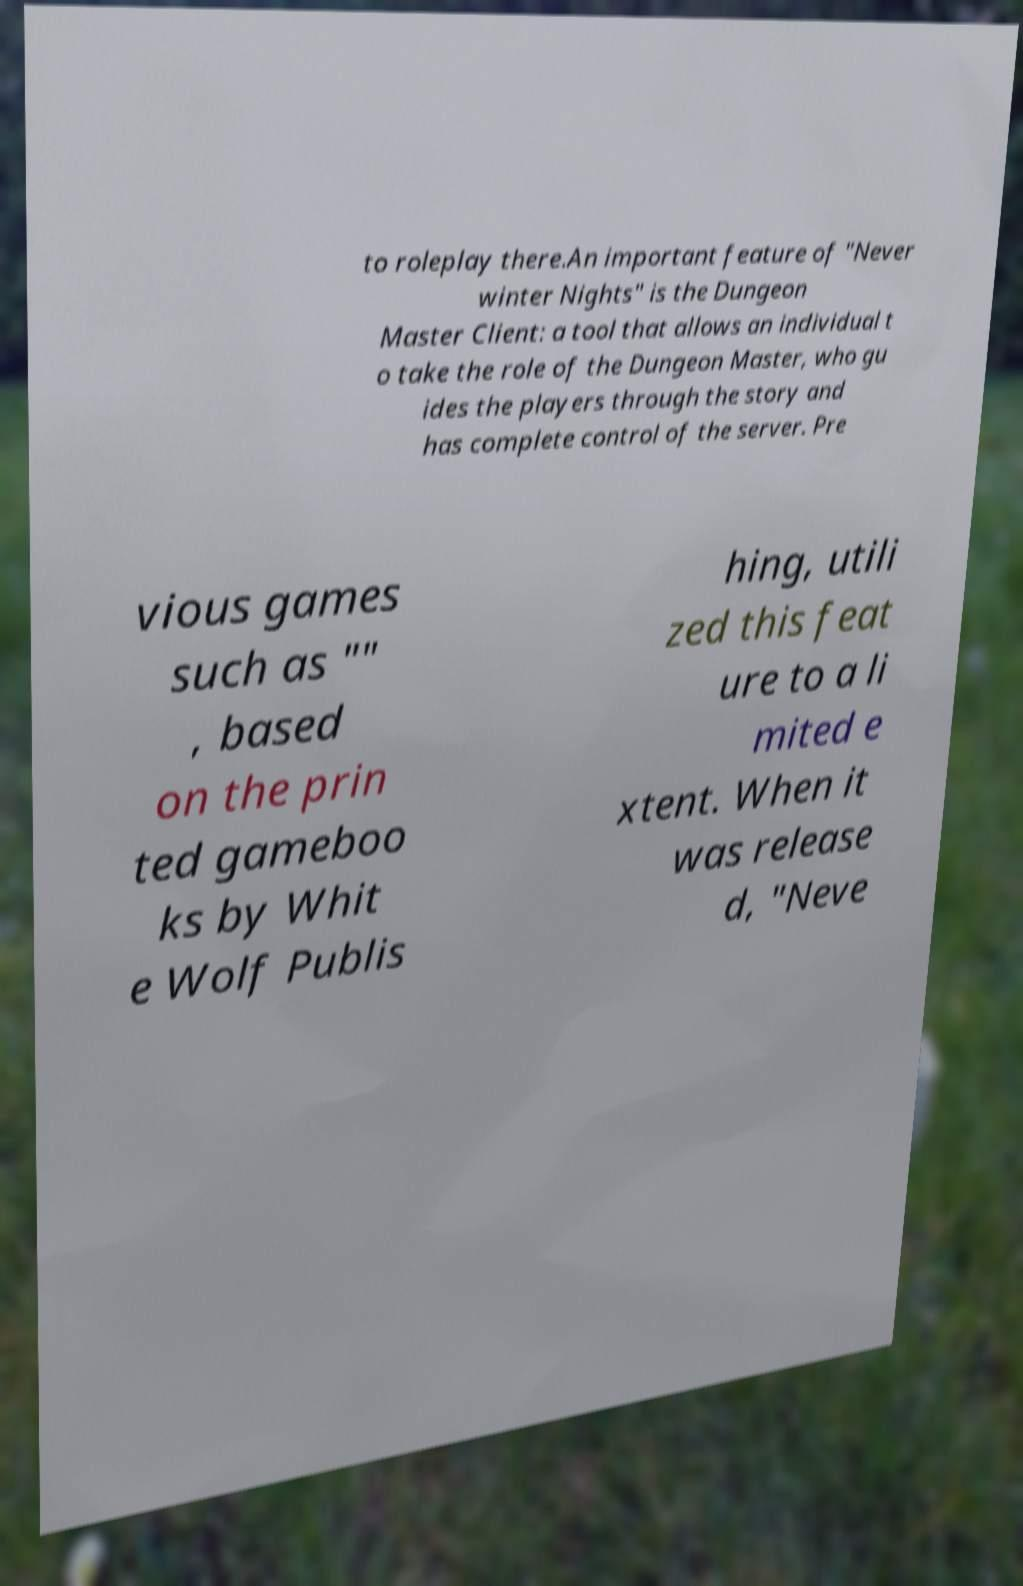Please read and relay the text visible in this image. What does it say? to roleplay there.An important feature of "Never winter Nights" is the Dungeon Master Client: a tool that allows an individual t o take the role of the Dungeon Master, who gu ides the players through the story and has complete control of the server. Pre vious games such as "" , based on the prin ted gameboo ks by Whit e Wolf Publis hing, utili zed this feat ure to a li mited e xtent. When it was release d, "Neve 